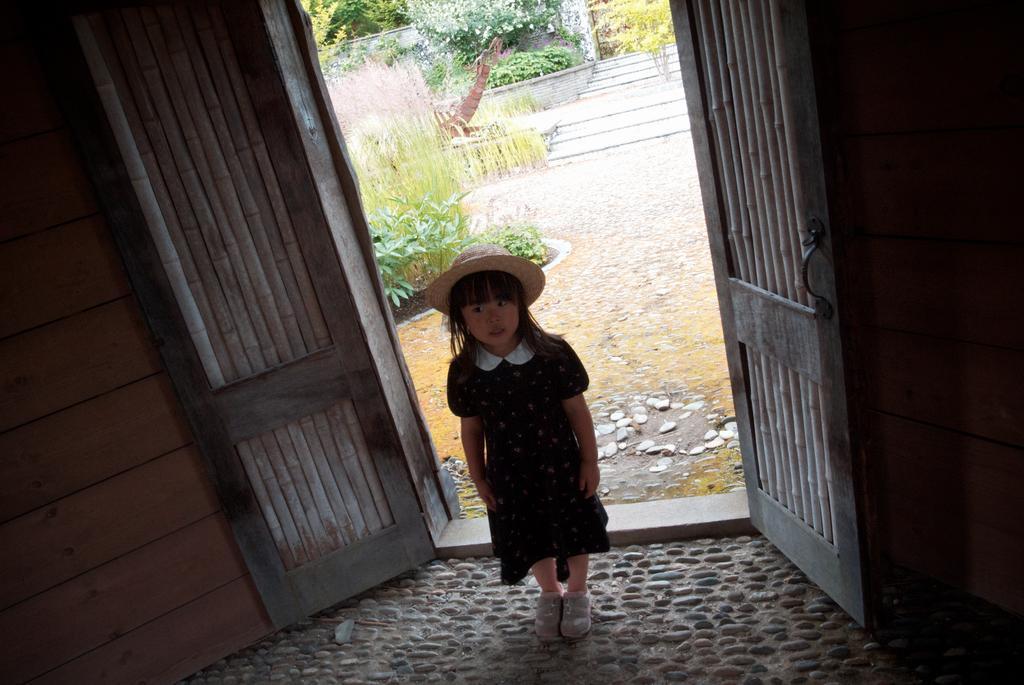Can you describe this image briefly? In this image in the middle there is a girl, she wears a dress, hat. At the bottom there is a floor. In the middle there are doors, plants, stones, staircase, trees, wall. 